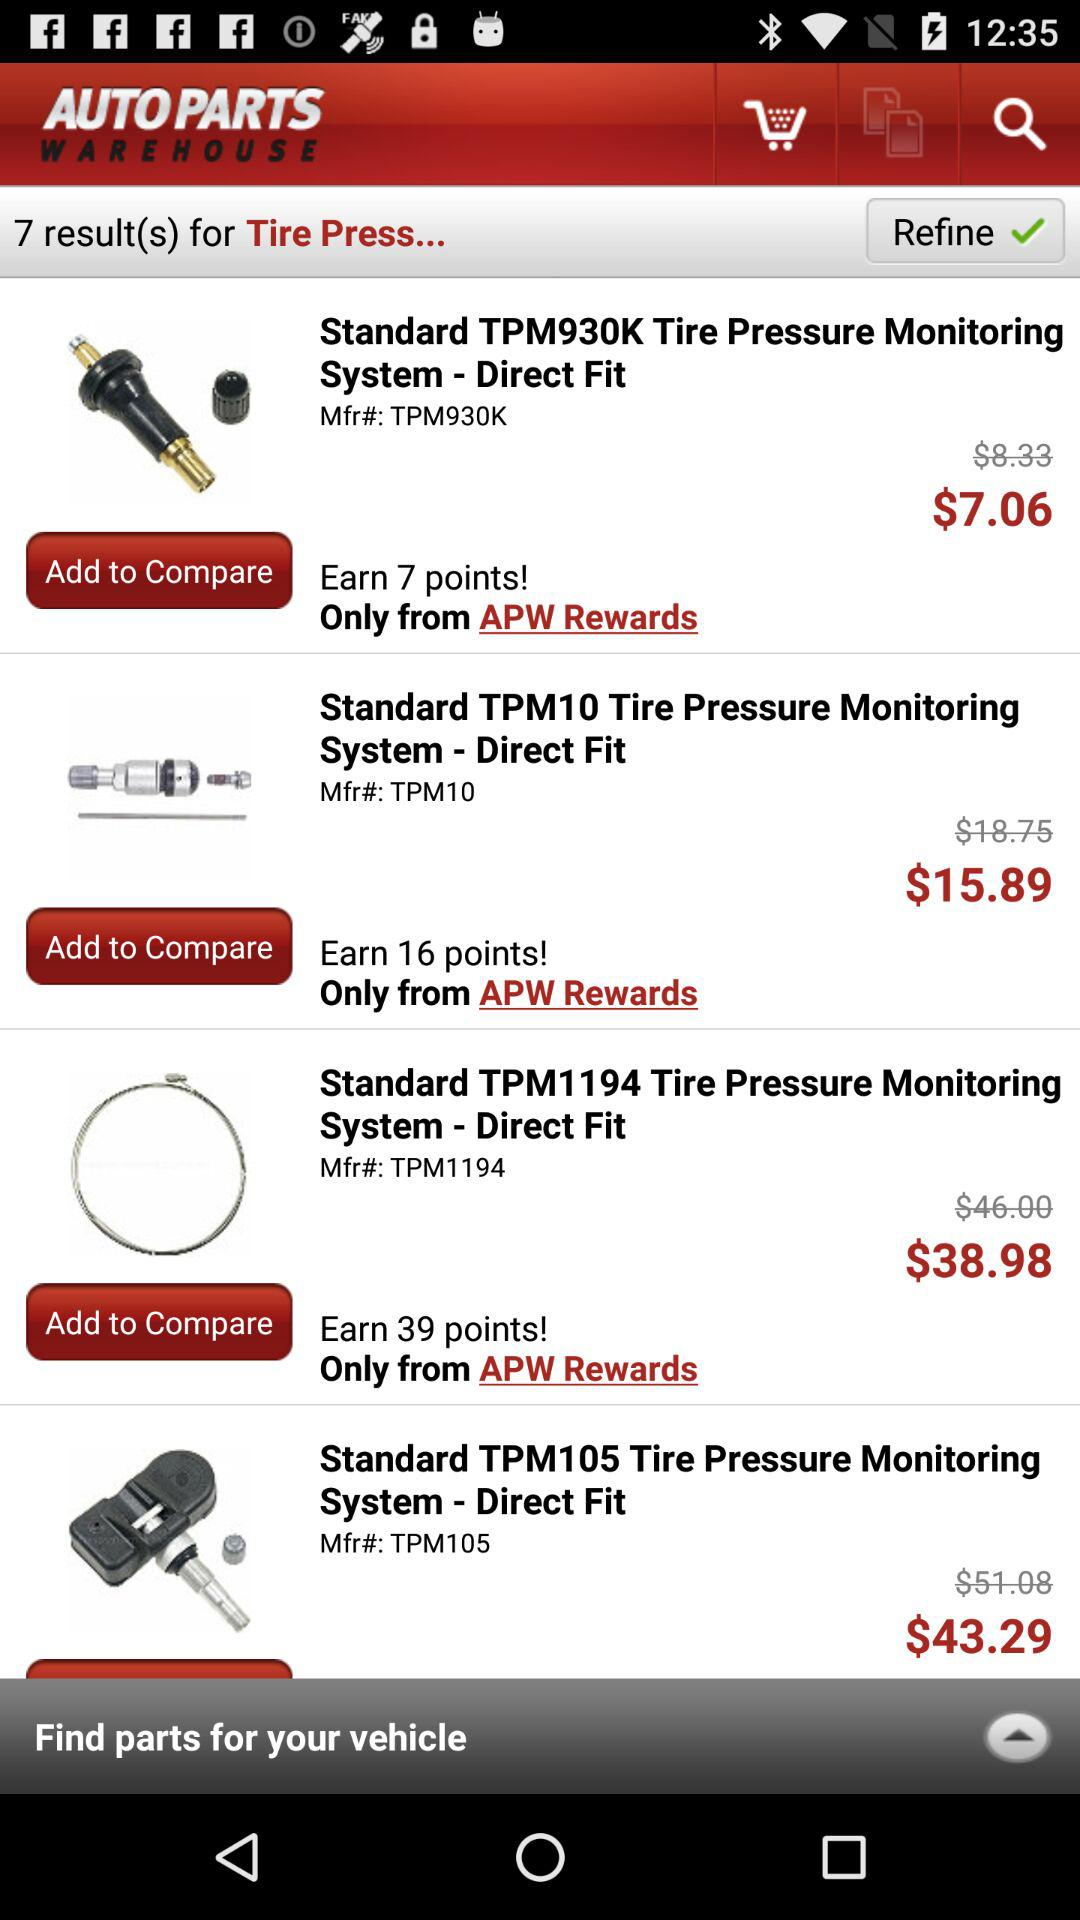How many points can I earn for purchasing standard TPM1194? You can earn 39 points. 